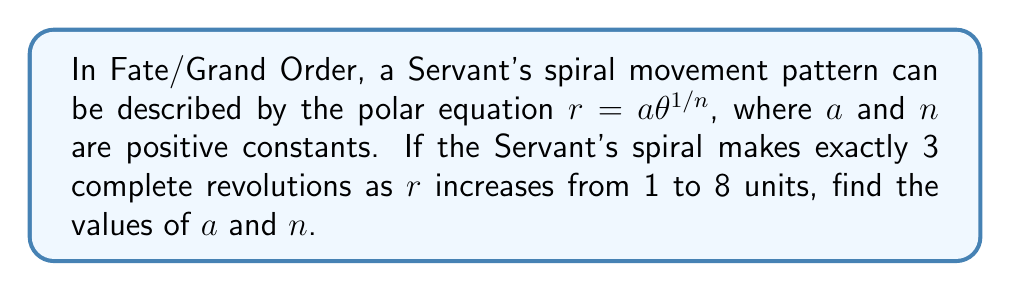Can you answer this question? Let's approach this step-by-step:

1) The general form of the spiral equation is $r = a\theta^{1/n}$.

2) We know that the spiral makes 3 complete revolutions, so $\theta$ goes from 0 to $6\pi$ radians.

3) At the start of the spiral, $r = 1$ and $\theta = 0$. However, $\theta = 0$ doesn't work in our equation, so we'll use the end point.

4) At the end of the spiral, $r = 8$ and $\theta = 6\pi$.

5) Substituting these values into our equation:

   $8 = a(6\pi)^{1/n}$

6) We can also write an equation for $r = 1$, which occurs when $\theta = 0$. Since $0^{1/n}$ is undefined, we'll use a very small angle, say $\epsilon$:

   $1 = a\epsilon^{1/n}$

7) Dividing the equation from step 5 by the equation from step 6:

   $\frac{8}{1} = \frac{a(6\pi)^{1/n}}{a\epsilon^{1/n}}$

8) The $a$'s cancel out:

   $8 = (\frac{6\pi}{\epsilon})^{1/n}$

9) Taking the natural log of both sides:

   $\ln 8 = \frac{1}{n}(\ln(6\pi) - \ln(\epsilon))$

10) As $\epsilon$ approaches 0, $\ln(\epsilon)$ approaches negative infinity, so $(\ln(6\pi) - \ln(\epsilon))$ approaches positive infinity. For the equation to hold, $n$ must approach infinity at the same rate.

11) Therefore, $n = \infty$.

12) Now that we know $n$, we can find $a$ using the equation from step 5:

    $8 = a(6\pi)^{1/\infty} = a \cdot 1 = a$

Therefore, $a = 8$.
Answer: $a = 8$ and $n = \infty$. The polar equation of the Servant's spiral movement pattern is $r = 8\theta^0 = 8$. 